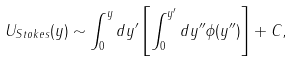<formula> <loc_0><loc_0><loc_500><loc_500>U _ { S t o k e s } ( y ) \sim \int _ { 0 } ^ { y } { d y ^ { \prime } \left [ \int _ { 0 } ^ { y ^ { \prime } } { d y ^ { \prime \prime } \phi ( y ^ { \prime \prime } ) } \right ] } + C ,</formula> 